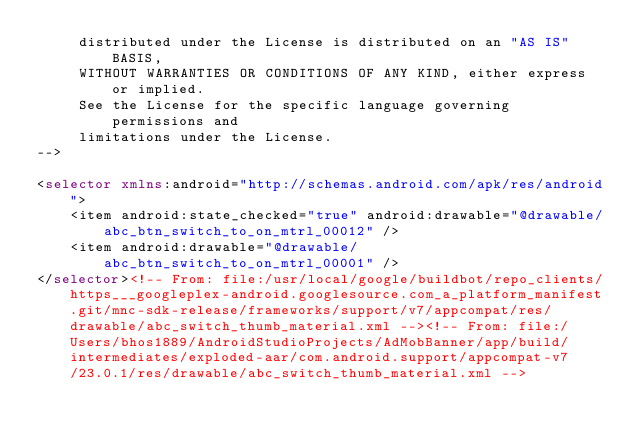Convert code to text. <code><loc_0><loc_0><loc_500><loc_500><_XML_>     distributed under the License is distributed on an "AS IS" BASIS,
     WITHOUT WARRANTIES OR CONDITIONS OF ANY KIND, either express or implied.
     See the License for the specific language governing permissions and
     limitations under the License.
-->

<selector xmlns:android="http://schemas.android.com/apk/res/android">
    <item android:state_checked="true" android:drawable="@drawable/abc_btn_switch_to_on_mtrl_00012" />
    <item android:drawable="@drawable/abc_btn_switch_to_on_mtrl_00001" />
</selector><!-- From: file:/usr/local/google/buildbot/repo_clients/https___googleplex-android.googlesource.com_a_platform_manifest.git/mnc-sdk-release/frameworks/support/v7/appcompat/res/drawable/abc_switch_thumb_material.xml --><!-- From: file:/Users/bhos1889/AndroidStudioProjects/AdMobBanner/app/build/intermediates/exploded-aar/com.android.support/appcompat-v7/23.0.1/res/drawable/abc_switch_thumb_material.xml --></code> 